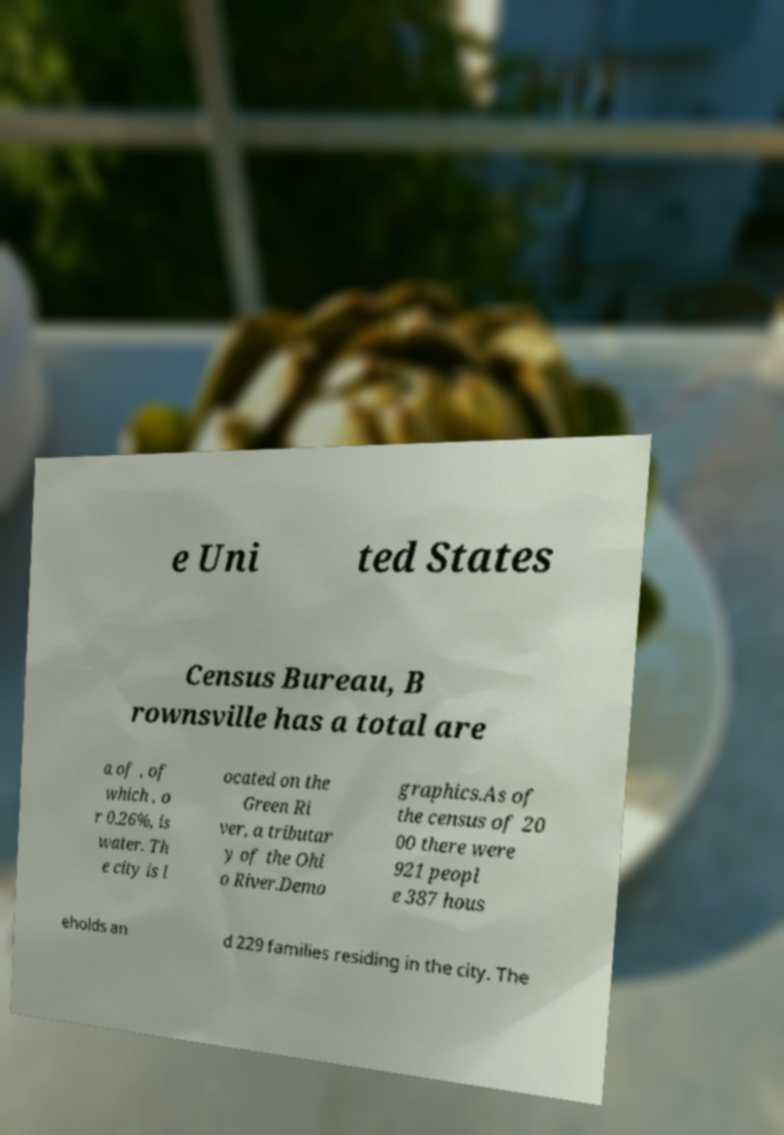For documentation purposes, I need the text within this image transcribed. Could you provide that? e Uni ted States Census Bureau, B rownsville has a total are a of , of which , o r 0.26%, is water. Th e city is l ocated on the Green Ri ver, a tributar y of the Ohi o River.Demo graphics.As of the census of 20 00 there were 921 peopl e 387 hous eholds an d 229 families residing in the city. The 